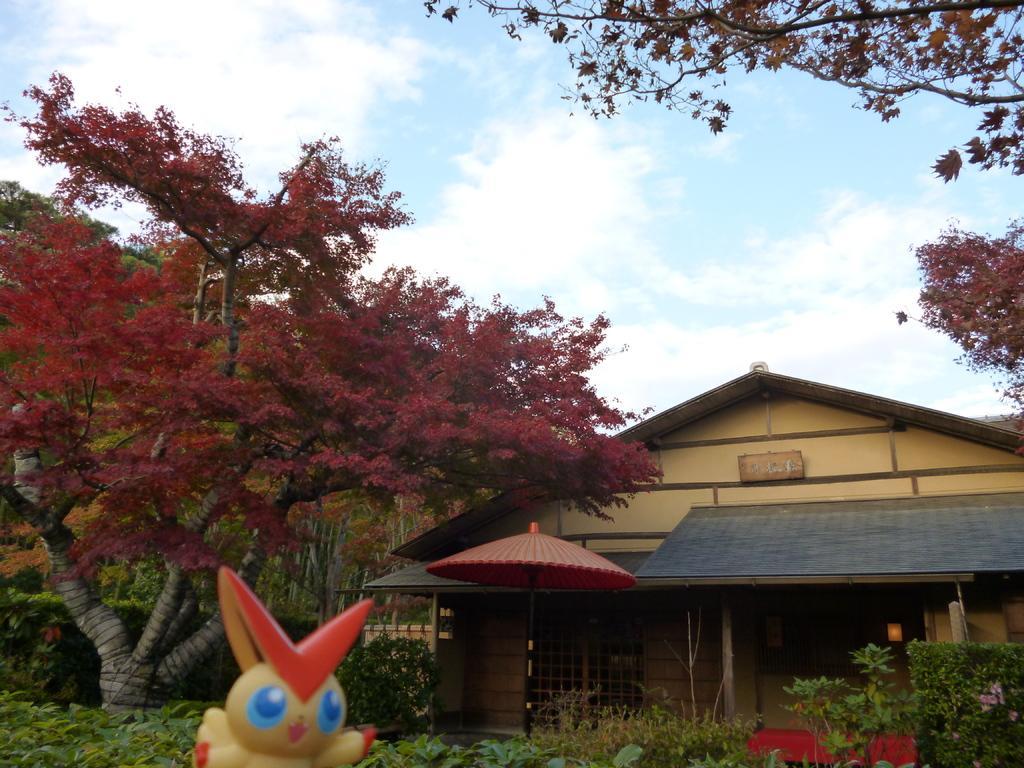How would you summarize this image in a sentence or two? In this picture I can see a house, trees and plants. Here I can see a toy and an umbrella. In the background I can see the sky 